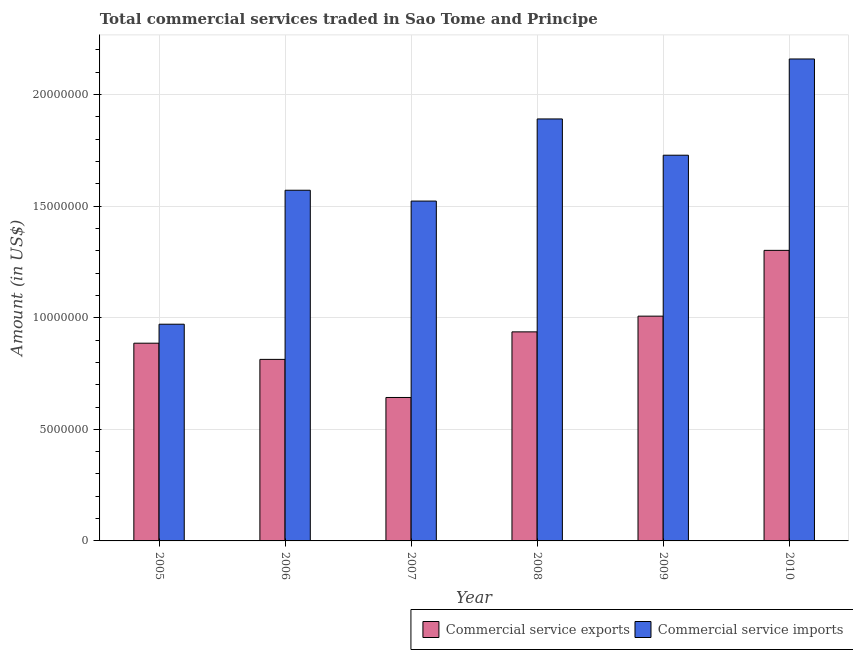How many groups of bars are there?
Your answer should be very brief. 6. How many bars are there on the 1st tick from the right?
Provide a short and direct response. 2. What is the label of the 3rd group of bars from the left?
Your response must be concise. 2007. What is the amount of commercial service exports in 2008?
Offer a terse response. 9.37e+06. Across all years, what is the maximum amount of commercial service imports?
Make the answer very short. 2.16e+07. Across all years, what is the minimum amount of commercial service imports?
Your answer should be very brief. 9.71e+06. In which year was the amount of commercial service imports maximum?
Offer a very short reply. 2010. What is the total amount of commercial service exports in the graph?
Ensure brevity in your answer.  5.59e+07. What is the difference between the amount of commercial service imports in 2007 and that in 2010?
Give a very brief answer. -6.37e+06. What is the difference between the amount of commercial service exports in 2006 and the amount of commercial service imports in 2009?
Your answer should be compact. -1.94e+06. What is the average amount of commercial service imports per year?
Keep it short and to the point. 1.64e+07. In the year 2010, what is the difference between the amount of commercial service imports and amount of commercial service exports?
Offer a very short reply. 0. In how many years, is the amount of commercial service exports greater than 18000000 US$?
Offer a very short reply. 0. What is the ratio of the amount of commercial service imports in 2006 to that in 2009?
Your answer should be very brief. 0.91. Is the amount of commercial service imports in 2005 less than that in 2007?
Offer a terse response. Yes. What is the difference between the highest and the second highest amount of commercial service imports?
Give a very brief answer. 2.69e+06. What is the difference between the highest and the lowest amount of commercial service imports?
Your answer should be very brief. 1.19e+07. In how many years, is the amount of commercial service exports greater than the average amount of commercial service exports taken over all years?
Offer a very short reply. 3. What does the 2nd bar from the left in 2005 represents?
Your response must be concise. Commercial service imports. What does the 2nd bar from the right in 2005 represents?
Offer a terse response. Commercial service exports. How many bars are there?
Give a very brief answer. 12. How many years are there in the graph?
Your response must be concise. 6. Are the values on the major ticks of Y-axis written in scientific E-notation?
Provide a succinct answer. No. What is the title of the graph?
Keep it short and to the point. Total commercial services traded in Sao Tome and Principe. Does "Short-term debt" appear as one of the legend labels in the graph?
Make the answer very short. No. What is the label or title of the X-axis?
Offer a very short reply. Year. What is the label or title of the Y-axis?
Offer a terse response. Amount (in US$). What is the Amount (in US$) in Commercial service exports in 2005?
Your answer should be compact. 8.86e+06. What is the Amount (in US$) in Commercial service imports in 2005?
Provide a short and direct response. 9.71e+06. What is the Amount (in US$) in Commercial service exports in 2006?
Offer a very short reply. 8.14e+06. What is the Amount (in US$) of Commercial service imports in 2006?
Your response must be concise. 1.57e+07. What is the Amount (in US$) in Commercial service exports in 2007?
Offer a very short reply. 6.43e+06. What is the Amount (in US$) in Commercial service imports in 2007?
Your answer should be very brief. 1.52e+07. What is the Amount (in US$) of Commercial service exports in 2008?
Your answer should be very brief. 9.37e+06. What is the Amount (in US$) in Commercial service imports in 2008?
Your response must be concise. 1.89e+07. What is the Amount (in US$) of Commercial service exports in 2009?
Give a very brief answer. 1.01e+07. What is the Amount (in US$) in Commercial service imports in 2009?
Keep it short and to the point. 1.73e+07. What is the Amount (in US$) in Commercial service exports in 2010?
Your response must be concise. 1.30e+07. What is the Amount (in US$) of Commercial service imports in 2010?
Your answer should be compact. 2.16e+07. Across all years, what is the maximum Amount (in US$) in Commercial service exports?
Keep it short and to the point. 1.30e+07. Across all years, what is the maximum Amount (in US$) in Commercial service imports?
Your response must be concise. 2.16e+07. Across all years, what is the minimum Amount (in US$) of Commercial service exports?
Provide a short and direct response. 6.43e+06. Across all years, what is the minimum Amount (in US$) of Commercial service imports?
Make the answer very short. 9.71e+06. What is the total Amount (in US$) of Commercial service exports in the graph?
Your answer should be very brief. 5.59e+07. What is the total Amount (in US$) in Commercial service imports in the graph?
Ensure brevity in your answer.  9.84e+07. What is the difference between the Amount (in US$) of Commercial service exports in 2005 and that in 2006?
Ensure brevity in your answer.  7.25e+05. What is the difference between the Amount (in US$) in Commercial service imports in 2005 and that in 2006?
Ensure brevity in your answer.  -6.00e+06. What is the difference between the Amount (in US$) of Commercial service exports in 2005 and that in 2007?
Your response must be concise. 2.43e+06. What is the difference between the Amount (in US$) of Commercial service imports in 2005 and that in 2007?
Keep it short and to the point. -5.52e+06. What is the difference between the Amount (in US$) in Commercial service exports in 2005 and that in 2008?
Make the answer very short. -5.08e+05. What is the difference between the Amount (in US$) of Commercial service imports in 2005 and that in 2008?
Offer a very short reply. -9.20e+06. What is the difference between the Amount (in US$) in Commercial service exports in 2005 and that in 2009?
Offer a terse response. -1.21e+06. What is the difference between the Amount (in US$) of Commercial service imports in 2005 and that in 2009?
Provide a succinct answer. -7.57e+06. What is the difference between the Amount (in US$) of Commercial service exports in 2005 and that in 2010?
Give a very brief answer. -4.16e+06. What is the difference between the Amount (in US$) in Commercial service imports in 2005 and that in 2010?
Your response must be concise. -1.19e+07. What is the difference between the Amount (in US$) of Commercial service exports in 2006 and that in 2007?
Your response must be concise. 1.71e+06. What is the difference between the Amount (in US$) of Commercial service imports in 2006 and that in 2007?
Ensure brevity in your answer.  4.85e+05. What is the difference between the Amount (in US$) of Commercial service exports in 2006 and that in 2008?
Your response must be concise. -1.23e+06. What is the difference between the Amount (in US$) in Commercial service imports in 2006 and that in 2008?
Offer a very short reply. -3.20e+06. What is the difference between the Amount (in US$) in Commercial service exports in 2006 and that in 2009?
Your response must be concise. -1.94e+06. What is the difference between the Amount (in US$) of Commercial service imports in 2006 and that in 2009?
Offer a very short reply. -1.57e+06. What is the difference between the Amount (in US$) in Commercial service exports in 2006 and that in 2010?
Your answer should be very brief. -4.89e+06. What is the difference between the Amount (in US$) in Commercial service imports in 2006 and that in 2010?
Give a very brief answer. -5.88e+06. What is the difference between the Amount (in US$) in Commercial service exports in 2007 and that in 2008?
Your answer should be very brief. -2.94e+06. What is the difference between the Amount (in US$) in Commercial service imports in 2007 and that in 2008?
Your answer should be compact. -3.68e+06. What is the difference between the Amount (in US$) in Commercial service exports in 2007 and that in 2009?
Your answer should be compact. -3.64e+06. What is the difference between the Amount (in US$) in Commercial service imports in 2007 and that in 2009?
Give a very brief answer. -2.06e+06. What is the difference between the Amount (in US$) of Commercial service exports in 2007 and that in 2010?
Keep it short and to the point. -6.59e+06. What is the difference between the Amount (in US$) of Commercial service imports in 2007 and that in 2010?
Make the answer very short. -6.37e+06. What is the difference between the Amount (in US$) in Commercial service exports in 2008 and that in 2009?
Provide a short and direct response. -7.04e+05. What is the difference between the Amount (in US$) in Commercial service imports in 2008 and that in 2009?
Your answer should be compact. 1.63e+06. What is the difference between the Amount (in US$) in Commercial service exports in 2008 and that in 2010?
Give a very brief answer. -3.65e+06. What is the difference between the Amount (in US$) of Commercial service imports in 2008 and that in 2010?
Make the answer very short. -2.69e+06. What is the difference between the Amount (in US$) in Commercial service exports in 2009 and that in 2010?
Offer a terse response. -2.95e+06. What is the difference between the Amount (in US$) of Commercial service imports in 2009 and that in 2010?
Your answer should be compact. -4.31e+06. What is the difference between the Amount (in US$) of Commercial service exports in 2005 and the Amount (in US$) of Commercial service imports in 2006?
Provide a succinct answer. -6.85e+06. What is the difference between the Amount (in US$) in Commercial service exports in 2005 and the Amount (in US$) in Commercial service imports in 2007?
Your response must be concise. -6.37e+06. What is the difference between the Amount (in US$) in Commercial service exports in 2005 and the Amount (in US$) in Commercial service imports in 2008?
Provide a succinct answer. -1.00e+07. What is the difference between the Amount (in US$) of Commercial service exports in 2005 and the Amount (in US$) of Commercial service imports in 2009?
Your response must be concise. -8.42e+06. What is the difference between the Amount (in US$) in Commercial service exports in 2005 and the Amount (in US$) in Commercial service imports in 2010?
Provide a short and direct response. -1.27e+07. What is the difference between the Amount (in US$) in Commercial service exports in 2006 and the Amount (in US$) in Commercial service imports in 2007?
Ensure brevity in your answer.  -7.09e+06. What is the difference between the Amount (in US$) in Commercial service exports in 2006 and the Amount (in US$) in Commercial service imports in 2008?
Your answer should be very brief. -1.08e+07. What is the difference between the Amount (in US$) of Commercial service exports in 2006 and the Amount (in US$) of Commercial service imports in 2009?
Offer a terse response. -9.15e+06. What is the difference between the Amount (in US$) of Commercial service exports in 2006 and the Amount (in US$) of Commercial service imports in 2010?
Make the answer very short. -1.35e+07. What is the difference between the Amount (in US$) of Commercial service exports in 2007 and the Amount (in US$) of Commercial service imports in 2008?
Your answer should be very brief. -1.25e+07. What is the difference between the Amount (in US$) of Commercial service exports in 2007 and the Amount (in US$) of Commercial service imports in 2009?
Make the answer very short. -1.09e+07. What is the difference between the Amount (in US$) of Commercial service exports in 2007 and the Amount (in US$) of Commercial service imports in 2010?
Offer a very short reply. -1.52e+07. What is the difference between the Amount (in US$) of Commercial service exports in 2008 and the Amount (in US$) of Commercial service imports in 2009?
Provide a succinct answer. -7.92e+06. What is the difference between the Amount (in US$) of Commercial service exports in 2008 and the Amount (in US$) of Commercial service imports in 2010?
Your response must be concise. -1.22e+07. What is the difference between the Amount (in US$) of Commercial service exports in 2009 and the Amount (in US$) of Commercial service imports in 2010?
Your answer should be compact. -1.15e+07. What is the average Amount (in US$) of Commercial service exports per year?
Offer a very short reply. 9.31e+06. What is the average Amount (in US$) of Commercial service imports per year?
Provide a succinct answer. 1.64e+07. In the year 2005, what is the difference between the Amount (in US$) in Commercial service exports and Amount (in US$) in Commercial service imports?
Make the answer very short. -8.51e+05. In the year 2006, what is the difference between the Amount (in US$) in Commercial service exports and Amount (in US$) in Commercial service imports?
Keep it short and to the point. -7.58e+06. In the year 2007, what is the difference between the Amount (in US$) of Commercial service exports and Amount (in US$) of Commercial service imports?
Offer a very short reply. -8.80e+06. In the year 2008, what is the difference between the Amount (in US$) in Commercial service exports and Amount (in US$) in Commercial service imports?
Offer a terse response. -9.54e+06. In the year 2009, what is the difference between the Amount (in US$) of Commercial service exports and Amount (in US$) of Commercial service imports?
Your answer should be very brief. -7.21e+06. In the year 2010, what is the difference between the Amount (in US$) of Commercial service exports and Amount (in US$) of Commercial service imports?
Provide a short and direct response. -8.58e+06. What is the ratio of the Amount (in US$) of Commercial service exports in 2005 to that in 2006?
Offer a very short reply. 1.09. What is the ratio of the Amount (in US$) of Commercial service imports in 2005 to that in 2006?
Keep it short and to the point. 0.62. What is the ratio of the Amount (in US$) of Commercial service exports in 2005 to that in 2007?
Provide a succinct answer. 1.38. What is the ratio of the Amount (in US$) of Commercial service imports in 2005 to that in 2007?
Your response must be concise. 0.64. What is the ratio of the Amount (in US$) in Commercial service exports in 2005 to that in 2008?
Your answer should be very brief. 0.95. What is the ratio of the Amount (in US$) in Commercial service imports in 2005 to that in 2008?
Make the answer very short. 0.51. What is the ratio of the Amount (in US$) of Commercial service exports in 2005 to that in 2009?
Give a very brief answer. 0.88. What is the ratio of the Amount (in US$) of Commercial service imports in 2005 to that in 2009?
Offer a terse response. 0.56. What is the ratio of the Amount (in US$) of Commercial service exports in 2005 to that in 2010?
Make the answer very short. 0.68. What is the ratio of the Amount (in US$) of Commercial service imports in 2005 to that in 2010?
Your answer should be very brief. 0.45. What is the ratio of the Amount (in US$) in Commercial service exports in 2006 to that in 2007?
Ensure brevity in your answer.  1.27. What is the ratio of the Amount (in US$) in Commercial service imports in 2006 to that in 2007?
Ensure brevity in your answer.  1.03. What is the ratio of the Amount (in US$) in Commercial service exports in 2006 to that in 2008?
Your answer should be very brief. 0.87. What is the ratio of the Amount (in US$) in Commercial service imports in 2006 to that in 2008?
Your answer should be compact. 0.83. What is the ratio of the Amount (in US$) of Commercial service exports in 2006 to that in 2009?
Provide a short and direct response. 0.81. What is the ratio of the Amount (in US$) of Commercial service imports in 2006 to that in 2009?
Offer a terse response. 0.91. What is the ratio of the Amount (in US$) of Commercial service exports in 2006 to that in 2010?
Offer a very short reply. 0.62. What is the ratio of the Amount (in US$) in Commercial service imports in 2006 to that in 2010?
Your response must be concise. 0.73. What is the ratio of the Amount (in US$) of Commercial service exports in 2007 to that in 2008?
Provide a short and direct response. 0.69. What is the ratio of the Amount (in US$) of Commercial service imports in 2007 to that in 2008?
Provide a succinct answer. 0.81. What is the ratio of the Amount (in US$) of Commercial service exports in 2007 to that in 2009?
Keep it short and to the point. 0.64. What is the ratio of the Amount (in US$) of Commercial service imports in 2007 to that in 2009?
Ensure brevity in your answer.  0.88. What is the ratio of the Amount (in US$) in Commercial service exports in 2007 to that in 2010?
Ensure brevity in your answer.  0.49. What is the ratio of the Amount (in US$) of Commercial service imports in 2007 to that in 2010?
Give a very brief answer. 0.71. What is the ratio of the Amount (in US$) in Commercial service exports in 2008 to that in 2009?
Provide a short and direct response. 0.93. What is the ratio of the Amount (in US$) in Commercial service imports in 2008 to that in 2009?
Keep it short and to the point. 1.09. What is the ratio of the Amount (in US$) in Commercial service exports in 2008 to that in 2010?
Provide a short and direct response. 0.72. What is the ratio of the Amount (in US$) of Commercial service imports in 2008 to that in 2010?
Provide a succinct answer. 0.88. What is the ratio of the Amount (in US$) of Commercial service exports in 2009 to that in 2010?
Make the answer very short. 0.77. What is the ratio of the Amount (in US$) in Commercial service imports in 2009 to that in 2010?
Ensure brevity in your answer.  0.8. What is the difference between the highest and the second highest Amount (in US$) in Commercial service exports?
Provide a succinct answer. 2.95e+06. What is the difference between the highest and the second highest Amount (in US$) in Commercial service imports?
Provide a succinct answer. 2.69e+06. What is the difference between the highest and the lowest Amount (in US$) of Commercial service exports?
Offer a very short reply. 6.59e+06. What is the difference between the highest and the lowest Amount (in US$) of Commercial service imports?
Keep it short and to the point. 1.19e+07. 